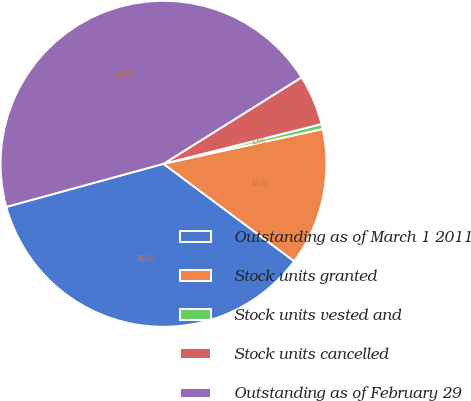Convert chart to OTSL. <chart><loc_0><loc_0><loc_500><loc_500><pie_chart><fcel>Outstanding as of March 1 2011<fcel>Stock units granted<fcel>Stock units vested and<fcel>Stock units cancelled<fcel>Outstanding as of February 29<nl><fcel>35.55%<fcel>13.62%<fcel>0.5%<fcel>4.98%<fcel>45.35%<nl></chart> 